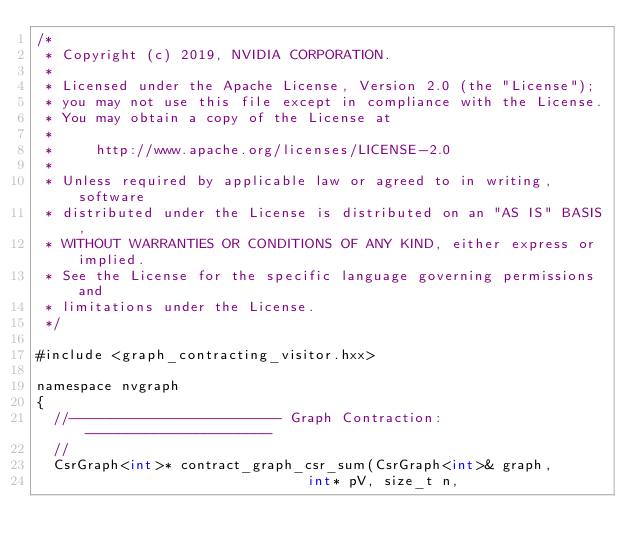<code> <loc_0><loc_0><loc_500><loc_500><_Cuda_>/*
 * Copyright (c) 2019, NVIDIA CORPORATION.
 *
 * Licensed under the Apache License, Version 2.0 (the "License");
 * you may not use this file except in compliance with the License.
 * You may obtain a copy of the License at
 *
 *     http://www.apache.org/licenses/LICENSE-2.0
 *
 * Unless required by applicable law or agreed to in writing, software
 * distributed under the License is distributed on an "AS IS" BASIS,
 * WITHOUT WARRANTIES OR CONDITIONS OF ANY KIND, either express or implied.
 * See the License for the specific language governing permissions and
 * limitations under the License.
 */

#include <graph_contracting_visitor.hxx>

namespace nvgraph
{
  //------------------------- Graph Contraction: ----------------------
  //
  CsrGraph<int>* contract_graph_csr_sum(CsrGraph<int>& graph,
                                int* pV, size_t n,</code> 